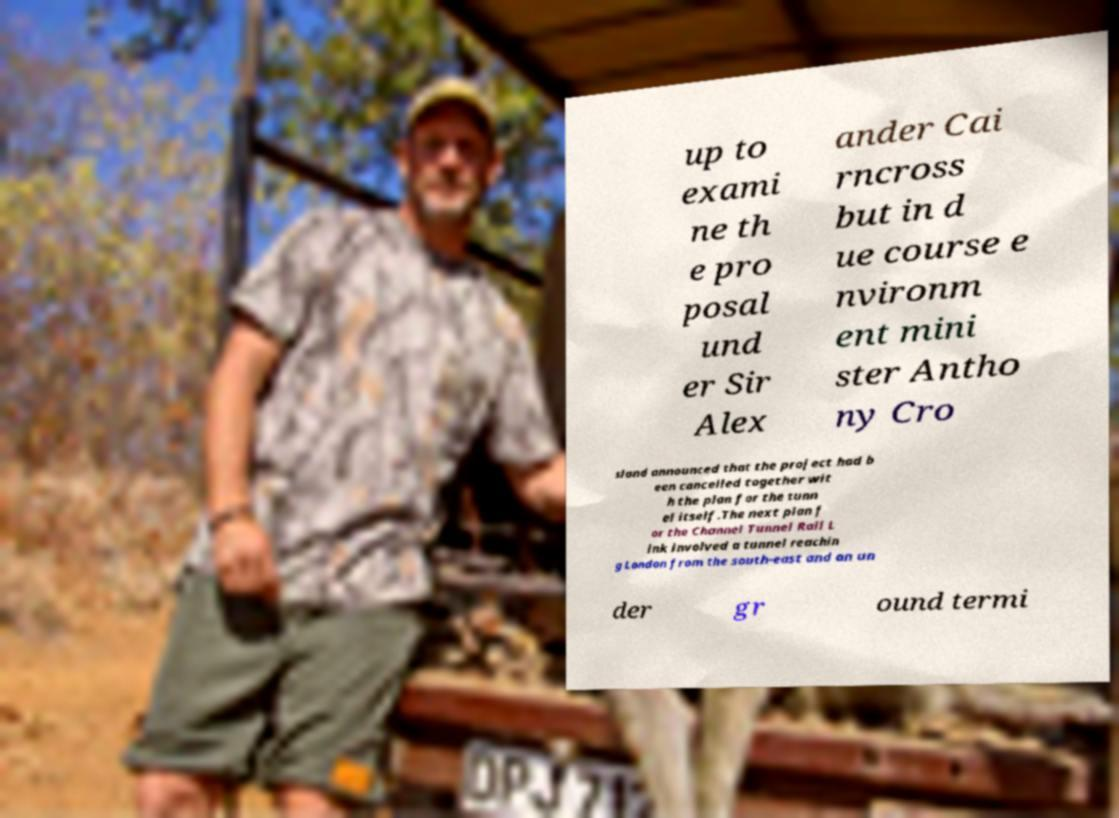Please read and relay the text visible in this image. What does it say? up to exami ne th e pro posal und er Sir Alex ander Cai rncross but in d ue course e nvironm ent mini ster Antho ny Cro sland announced that the project had b een cancelled together wit h the plan for the tunn el itself.The next plan f or the Channel Tunnel Rail L ink involved a tunnel reachin g London from the south-east and an un der gr ound termi 